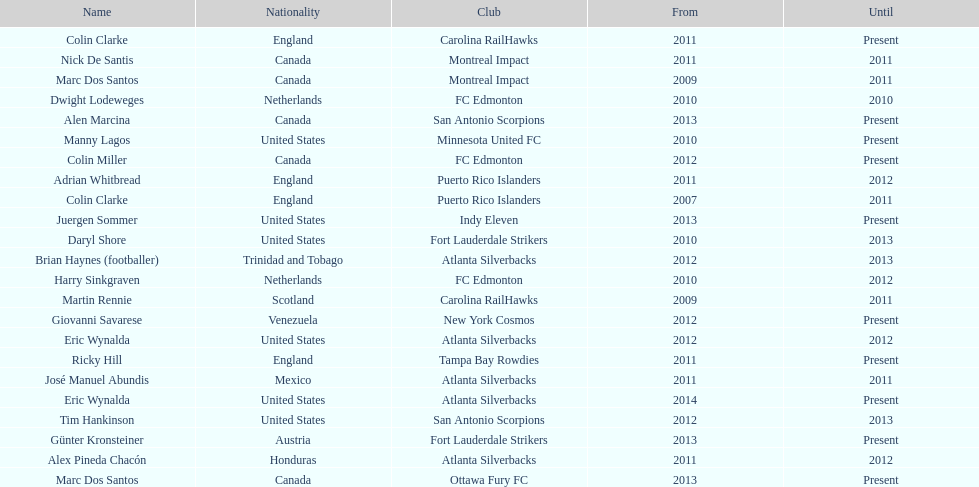Marc dos santos started as coach the same year as what other coach? Martin Rennie. Could you help me parse every detail presented in this table? {'header': ['Name', 'Nationality', 'Club', 'From', 'Until'], 'rows': [['Colin Clarke', 'England', 'Carolina RailHawks', '2011', 'Present'], ['Nick De Santis', 'Canada', 'Montreal Impact', '2011', '2011'], ['Marc Dos Santos', 'Canada', 'Montreal Impact', '2009', '2011'], ['Dwight Lodeweges', 'Netherlands', 'FC Edmonton', '2010', '2010'], ['Alen Marcina', 'Canada', 'San Antonio Scorpions', '2013', 'Present'], ['Manny Lagos', 'United States', 'Minnesota United FC', '2010', 'Present'], ['Colin Miller', 'Canada', 'FC Edmonton', '2012', 'Present'], ['Adrian Whitbread', 'England', 'Puerto Rico Islanders', '2011', '2012'], ['Colin Clarke', 'England', 'Puerto Rico Islanders', '2007', '2011'], ['Juergen Sommer', 'United States', 'Indy Eleven', '2013', 'Present'], ['Daryl Shore', 'United States', 'Fort Lauderdale Strikers', '2010', '2013'], ['Brian Haynes (footballer)', 'Trinidad and Tobago', 'Atlanta Silverbacks', '2012', '2013'], ['Harry Sinkgraven', 'Netherlands', 'FC Edmonton', '2010', '2012'], ['Martin Rennie', 'Scotland', 'Carolina RailHawks', '2009', '2011'], ['Giovanni Savarese', 'Venezuela', 'New York Cosmos', '2012', 'Present'], ['Eric Wynalda', 'United States', 'Atlanta Silverbacks', '2012', '2012'], ['Ricky Hill', 'England', 'Tampa Bay Rowdies', '2011', 'Present'], ['José Manuel Abundis', 'Mexico', 'Atlanta Silverbacks', '2011', '2011'], ['Eric Wynalda', 'United States', 'Atlanta Silverbacks', '2014', 'Present'], ['Tim Hankinson', 'United States', 'San Antonio Scorpions', '2012', '2013'], ['Günter Kronsteiner', 'Austria', 'Fort Lauderdale Strikers', '2013', 'Present'], ['Alex Pineda Chacón', 'Honduras', 'Atlanta Silverbacks', '2011', '2012'], ['Marc Dos Santos', 'Canada', 'Ottawa Fury FC', '2013', 'Present']]} 